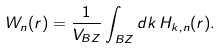<formula> <loc_0><loc_0><loc_500><loc_500>W _ { n } ( r ) = \frac { 1 } { V _ { B Z } } \int _ { B Z } d k \, H _ { k , n } ( r ) .</formula> 